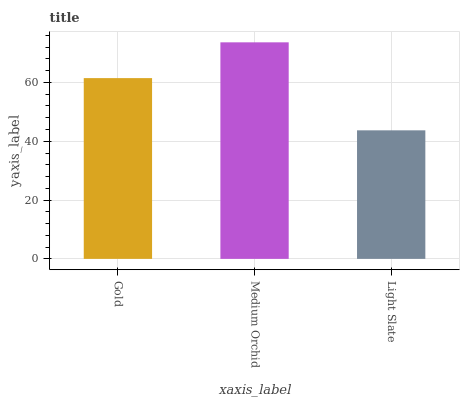Is Light Slate the minimum?
Answer yes or no. Yes. Is Medium Orchid the maximum?
Answer yes or no. Yes. Is Medium Orchid the minimum?
Answer yes or no. No. Is Light Slate the maximum?
Answer yes or no. No. Is Medium Orchid greater than Light Slate?
Answer yes or no. Yes. Is Light Slate less than Medium Orchid?
Answer yes or no. Yes. Is Light Slate greater than Medium Orchid?
Answer yes or no. No. Is Medium Orchid less than Light Slate?
Answer yes or no. No. Is Gold the high median?
Answer yes or no. Yes. Is Gold the low median?
Answer yes or no. Yes. Is Light Slate the high median?
Answer yes or no. No. Is Medium Orchid the low median?
Answer yes or no. No. 